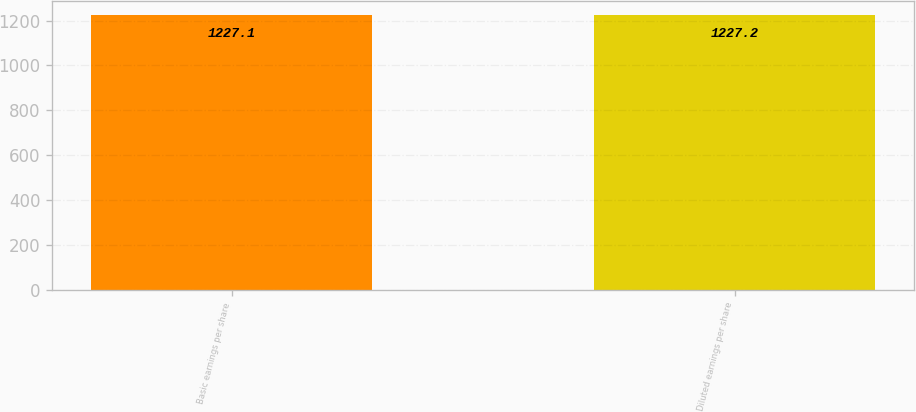Convert chart. <chart><loc_0><loc_0><loc_500><loc_500><bar_chart><fcel>Basic earnings per share<fcel>Diluted earnings per share<nl><fcel>1227.1<fcel>1227.2<nl></chart> 